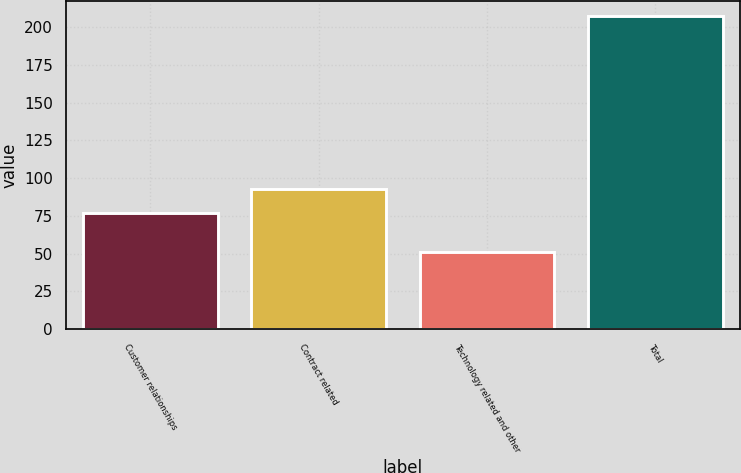Convert chart to OTSL. <chart><loc_0><loc_0><loc_500><loc_500><bar_chart><fcel>Customer relationships<fcel>Contract related<fcel>Technology related and other<fcel>Total<nl><fcel>77<fcel>92.6<fcel>51<fcel>207<nl></chart> 